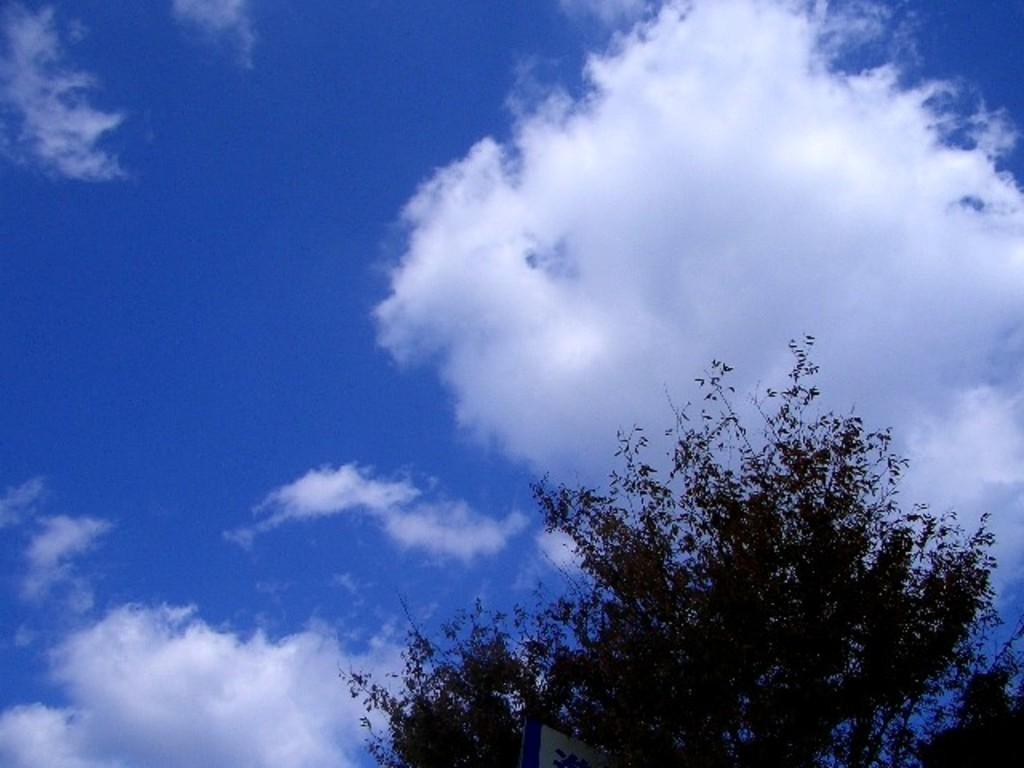Could you give a brief overview of what you see in this image? In this image we can see a tree and a board. Behind the tree we can see the clear sky. 